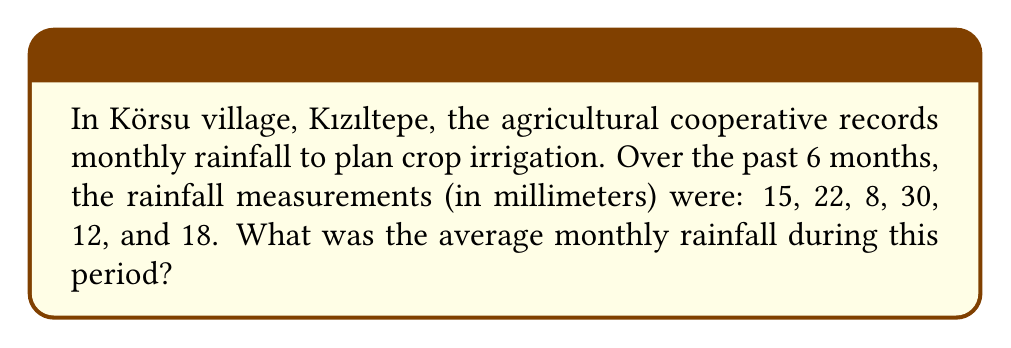What is the answer to this math problem? To find the average monthly rainfall, we need to sum up all the rainfall measurements and divide by the number of months. Let's break this down step-by-step:

1. List the rainfall measurements:
   $15, 22, 8, 30, 12, 18$ (in mm)

2. Calculate the sum of all measurements:
   $S = 15 + 22 + 8 + 30 + 12 + 18 = 105$ mm

3. Count the number of months:
   $n = 6$ months

4. Apply the formula for arithmetic mean (average):
   $$ \text{Average} = \frac{\text{Sum of measurements}}{\text{Number of measurements}} $$

   $$ \text{Average} = \frac{S}{n} = \frac{105}{6} = 17.5 \text{ mm} $$

Therefore, the average monthly rainfall over the 6-month period was 17.5 mm.
Answer: $17.5 \text{ mm}$ 